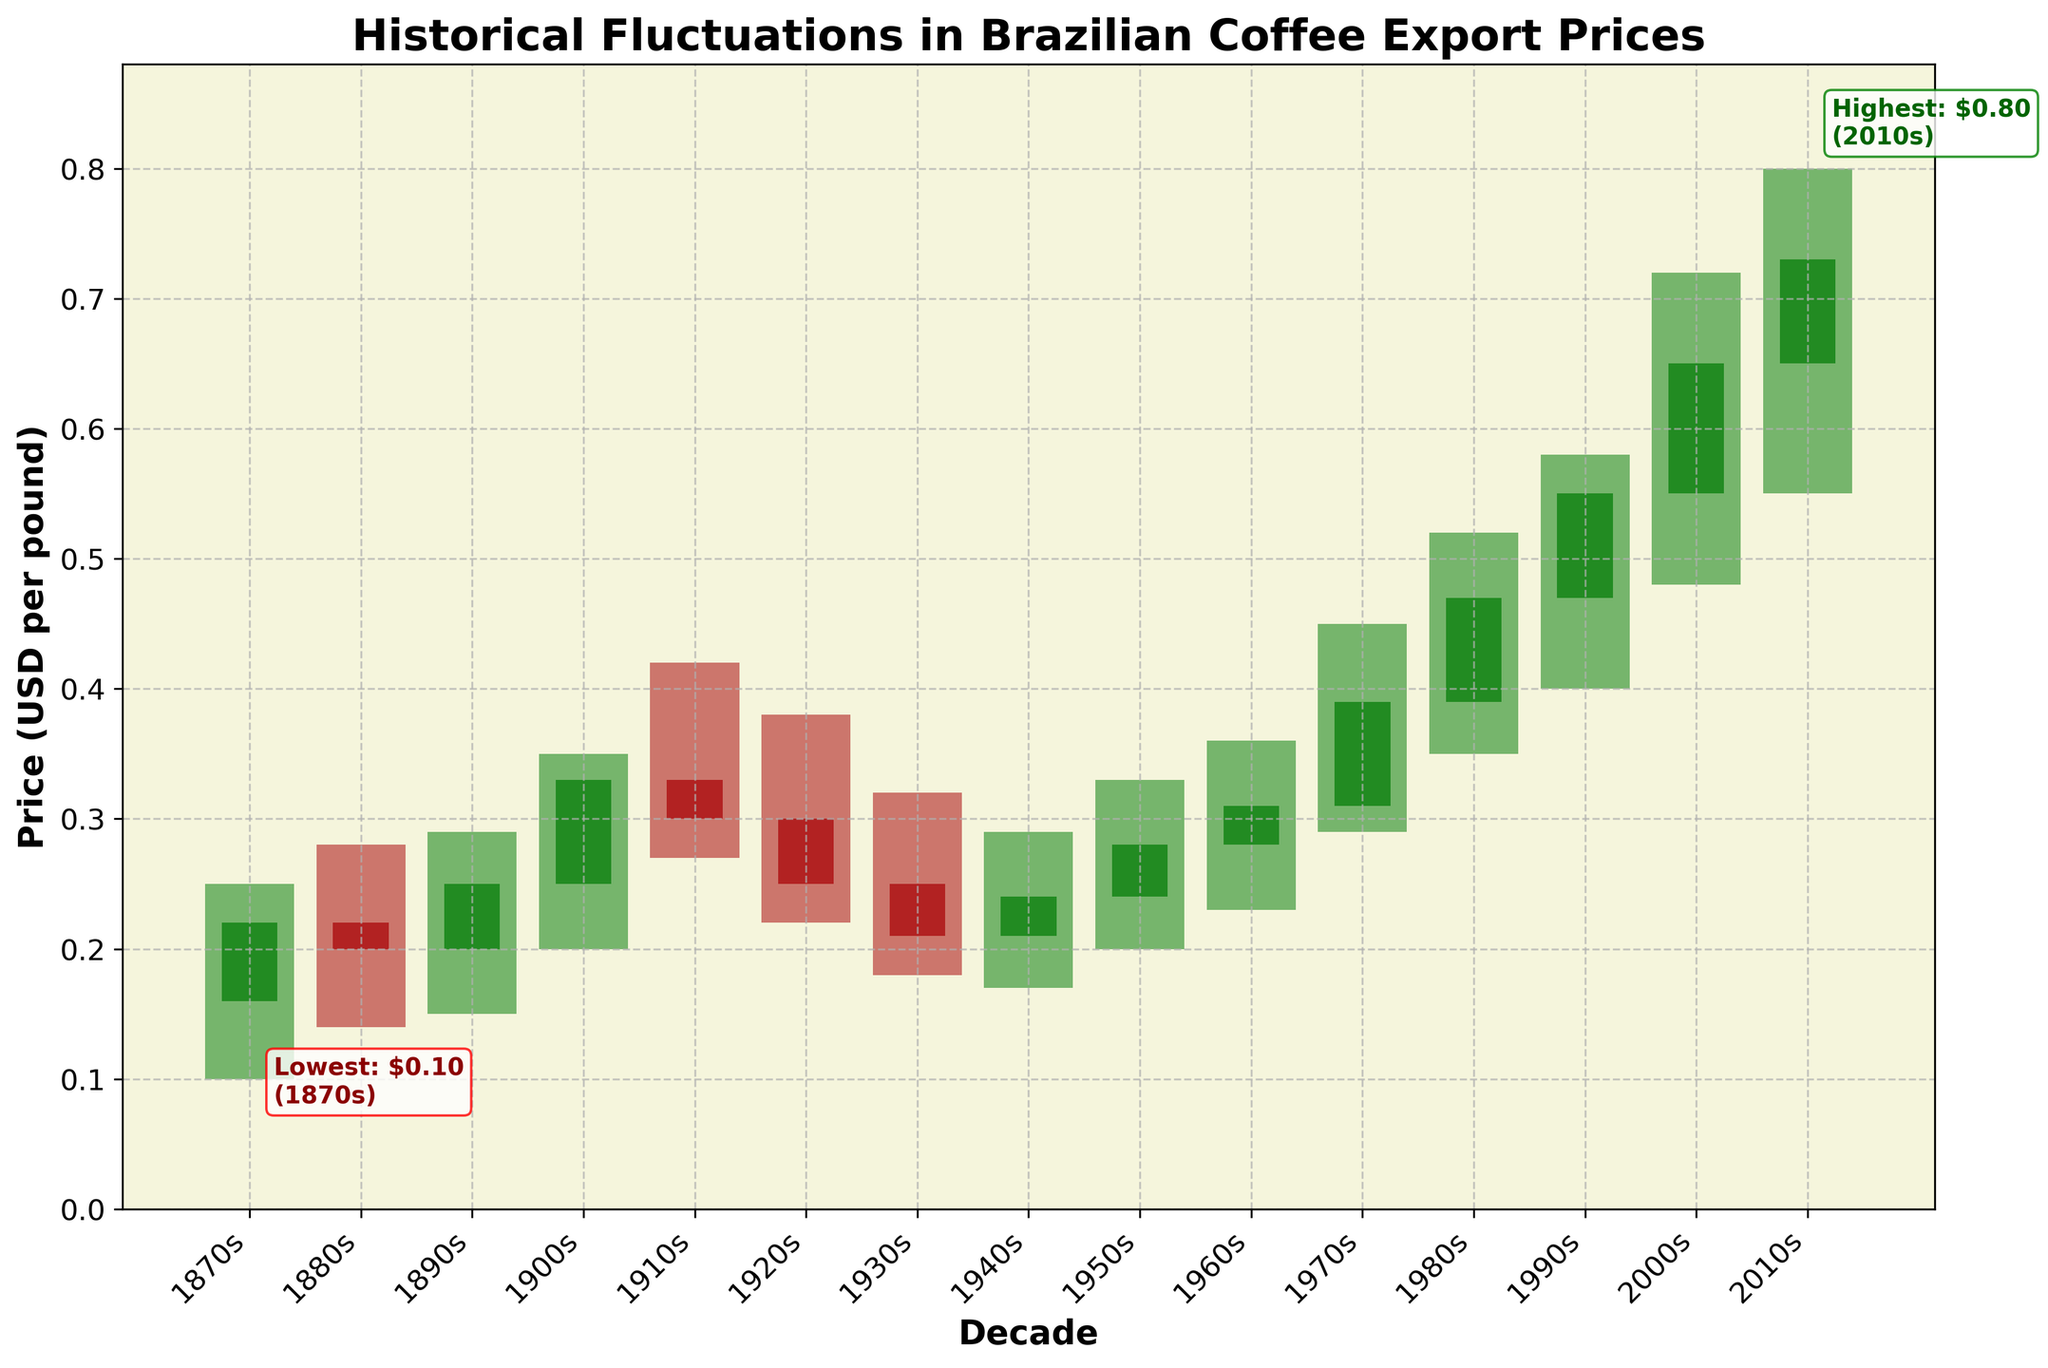What's the title of the candlestick plot? The title is usually found at the top of the plot and is a summary of what the plot represents. In this case, it reads 'Historical Fluctuations in Brazilian Coffee Export Prices'.
Answer: 'Historical Fluctuations in Brazilian Coffee Export Prices' How many decades are depicted in the plot? To determine the number of decades, count the number of distinct tick marks on the x-axis, each representing a decade. This plot spans from the 1870s to the 2010s.
Answer: 15 Which decade had the highest coffee export price and what was it? The highest price can be identified by the tallest "high" value among the candlesticks. Annotated, it shows the 2000s had the highest price of $0.80.
Answer: 2000s, $0.80 Which decade had the lowest coffee export price and what was it? The lowest price can be identified by the shortest "low" value among the candlesticks. Annotated, it shows the 1870s had the lowest price of $0.10.
Answer: 1870s, $0.10 During which decade did the coffee export price close significantly higher than it opened? Look for a green candlestick where the close value is higher than the open value by a noticeable margin. In the 1900s, the price opened at $0.25 and closed at $0.33.
Answer: 1900s What was the average closing price for the decades displayed? Add up all the closing prices for each decade and then divide by the number of decades: (0.22 + 0.20 + 0.25 + 0.33 + 0.30 + 0.25 + 0.21 + 0.24 + 0.28 + 0.31 + 0.39 + 0.47 + 0.55 + 0.65 + 0.73) / 15 = 0.35
Answer: $0.35 Which two decades had the smallest fluctuations in coffee export prices? The smallest fluctuation means the smallest difference between high and low values. In this case, the 1880s (0.28 - 0.14 = 0.14) and the 1940s (0.29 - 0.17 = 0.12) had the smallest price fluctuations.
Answer: 1880s and 1940s Did the coffee export prices increase or decrease from the 1950s to the 1960s? Compare the closing price of the 1950s with that of the 1960s. The closing price rose from $0.28 in the 1950s to $0.31 in the 1960s indicating an increase.
Answer: Increased Which decade had the most dramatic increase in coffee export price within the decade? Look for a green candlestick with the largest height difference between its open and close prices. The 1980s had an increase from $0.39 to $0.47.
Answer: 1980s 